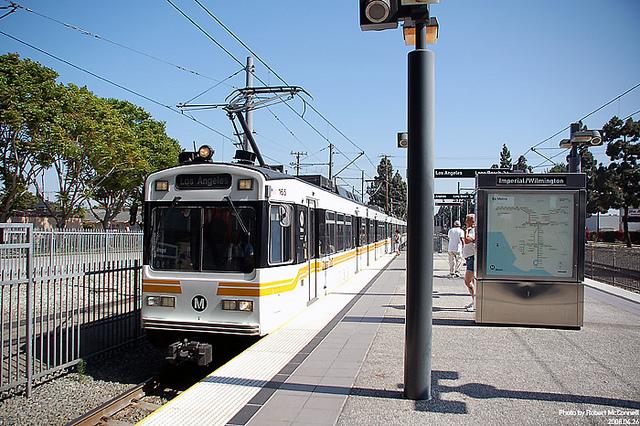How many maps are in the photo?
Be succinct. 1. Is this a commuter train?
Answer briefly. Yes. What letter is on the front of the train?
Keep it brief. M. 